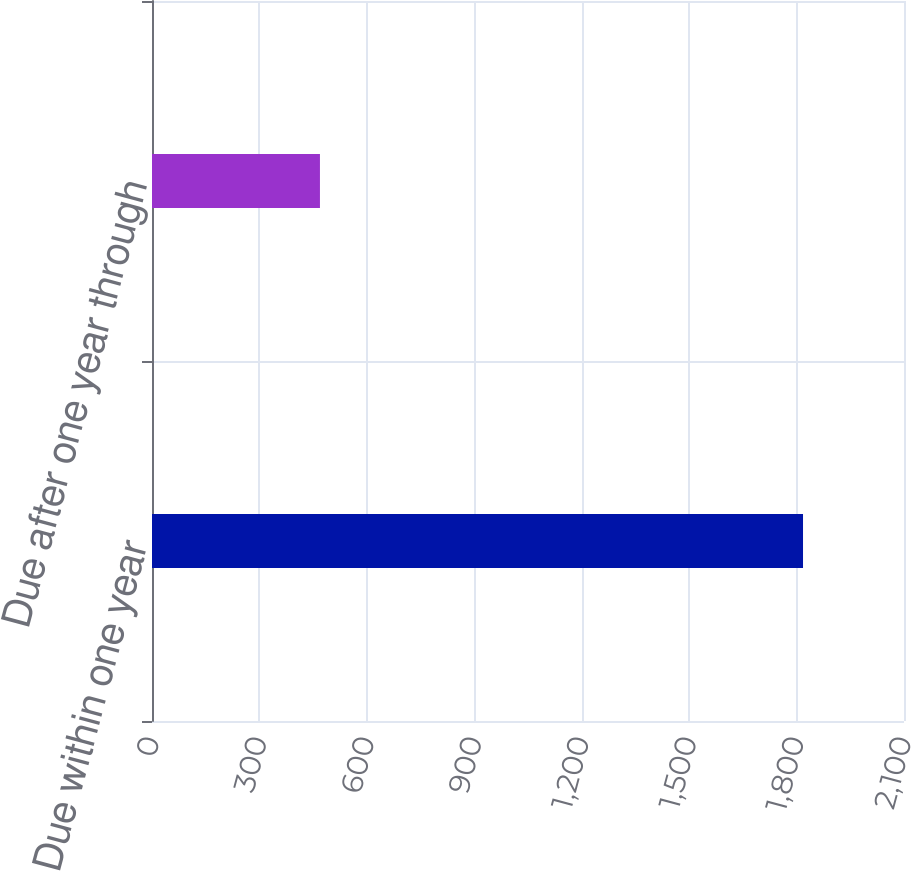Convert chart to OTSL. <chart><loc_0><loc_0><loc_500><loc_500><bar_chart><fcel>Due within one year<fcel>Due after one year through<nl><fcel>1818<fcel>469<nl></chart> 